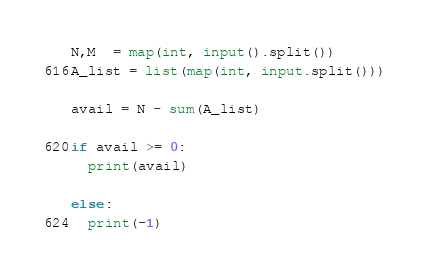Convert code to text. <code><loc_0><loc_0><loc_500><loc_500><_Python_>N,M  = map(int, input().split())
A_list = list(map(int, input.split()))

avail = N - sum(A_list)

if avail >= 0: 
  print(avail)
  
else:
  print(-1)</code> 